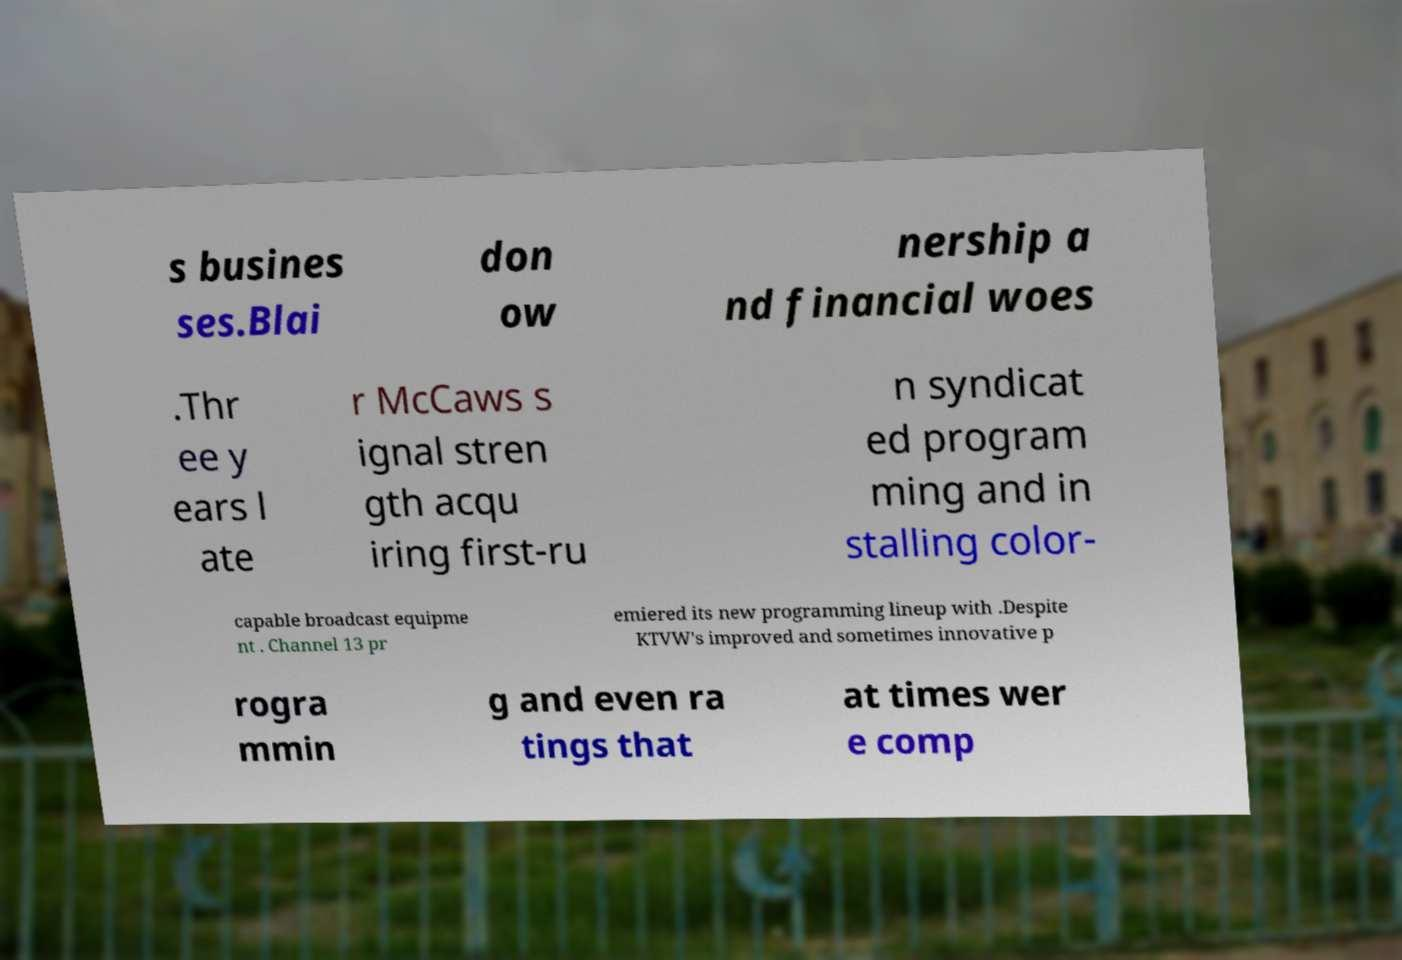Can you read and provide the text displayed in the image?This photo seems to have some interesting text. Can you extract and type it out for me? s busines ses.Blai don ow nership a nd financial woes .Thr ee y ears l ate r McCaws s ignal stren gth acqu iring first-ru n syndicat ed program ming and in stalling color- capable broadcast equipme nt . Channel 13 pr emiered its new programming lineup with .Despite KTVW's improved and sometimes innovative p rogra mmin g and even ra tings that at times wer e comp 